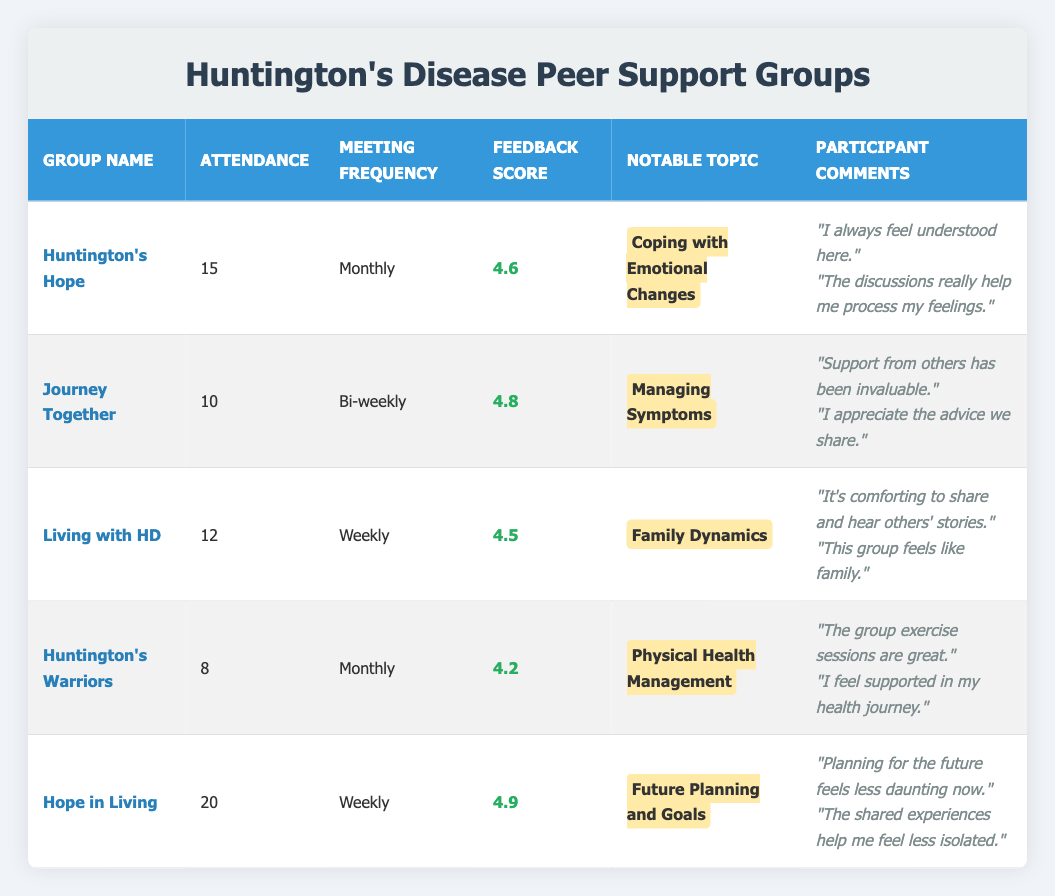What is the feedback score for "Journey Together"? According to the table, the feedback score for "Journey Together" is listed directly next to the group name in the feedback score column. The score is 4.8.
Answer: 4.8 Which group has the highest attendance? By scanning the attendance column for all groups, "Hope in Living" has the highest attendance of 20 members.
Answer: Hope in Living What is the meeting frequency for "Living with HD"? The table provides the meeting frequency for each group in a dedicated column. "Living with HD" has a meeting frequency of "Weekly."
Answer: Weekly How many people attended "Huntington's Warriors"? The attendance for "Huntington's Warriors" is explicitly stated in the attendance column. It shows that 8 people attended.
Answer: 8 What notable topic was discussed in "Huntington's Hope"? The table includes a column for the notable topics discussed in each group. For "Huntington's Hope," the notable topic is "Coping with Emotional Changes."
Answer: Coping with Emotional Changes What is the average feedback score of all groups? First, we need to sum the feedback scores from all groups: 4.6 + 4.8 + 4.5 + 4.2 + 4.9 = 24. The average is calculated by dividing the total by the number of groups, which is 5. Thus, 24 / 5 = 4.8.
Answer: 4.8 Is the feedback score for "Huntington's Warriors" lower than 4.5? By comparing the feedback score for "Huntington's Warriors," which is 4.2, with 4.5, we see that 4.2 is indeed lower than 4.5.
Answer: Yes How many groups meet monthly, and what is their average attendance? We identify the monthly groups, which are "Huntington's Hope" (15) and "Huntington's Warriors" (8). To find the average, sum the attendances: 15 + 8 = 23, then divide by 2 (the number of monthly groups): 23 / 2 = 11.5.
Answer: 11.5 Which group discussed "Future Planning and Goals," and what was its feedback score? The table shows that "Hope in Living" is the group that discussed "Future Planning and Goals." Its feedback score is listed as 4.9.
Answer: Hope in Living, 4.9 How does the attendance of "Journey Together" compare to "Living with HD"? The attendance for "Journey Together" is 10, while "Living with HD" has an attendance of 12. Since 12 is greater than 10, "Living with HD" has higher attendance.
Answer: Living with HD has higher attendance 